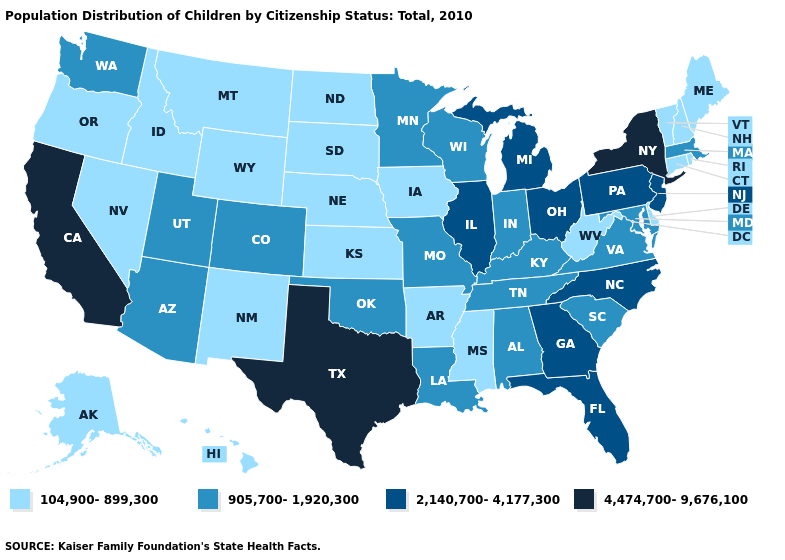Does the map have missing data?
Give a very brief answer. No. Does the first symbol in the legend represent the smallest category?
Give a very brief answer. Yes. Among the states that border Minnesota , which have the highest value?
Give a very brief answer. Wisconsin. Name the states that have a value in the range 905,700-1,920,300?
Short answer required. Alabama, Arizona, Colorado, Indiana, Kentucky, Louisiana, Maryland, Massachusetts, Minnesota, Missouri, Oklahoma, South Carolina, Tennessee, Utah, Virginia, Washington, Wisconsin. Does North Dakota have the lowest value in the MidWest?
Give a very brief answer. Yes. Name the states that have a value in the range 104,900-899,300?
Quick response, please. Alaska, Arkansas, Connecticut, Delaware, Hawaii, Idaho, Iowa, Kansas, Maine, Mississippi, Montana, Nebraska, Nevada, New Hampshire, New Mexico, North Dakota, Oregon, Rhode Island, South Dakota, Vermont, West Virginia, Wyoming. Does Indiana have a higher value than Texas?
Quick response, please. No. Does the map have missing data?
Be succinct. No. Name the states that have a value in the range 4,474,700-9,676,100?
Keep it brief. California, New York, Texas. Which states have the lowest value in the Northeast?
Keep it brief. Connecticut, Maine, New Hampshire, Rhode Island, Vermont. What is the highest value in the USA?
Quick response, please. 4,474,700-9,676,100. Name the states that have a value in the range 4,474,700-9,676,100?
Be succinct. California, New York, Texas. What is the value of Washington?
Quick response, please. 905,700-1,920,300. Does Alabama have the same value as Missouri?
Keep it brief. Yes. What is the lowest value in the USA?
Quick response, please. 104,900-899,300. 